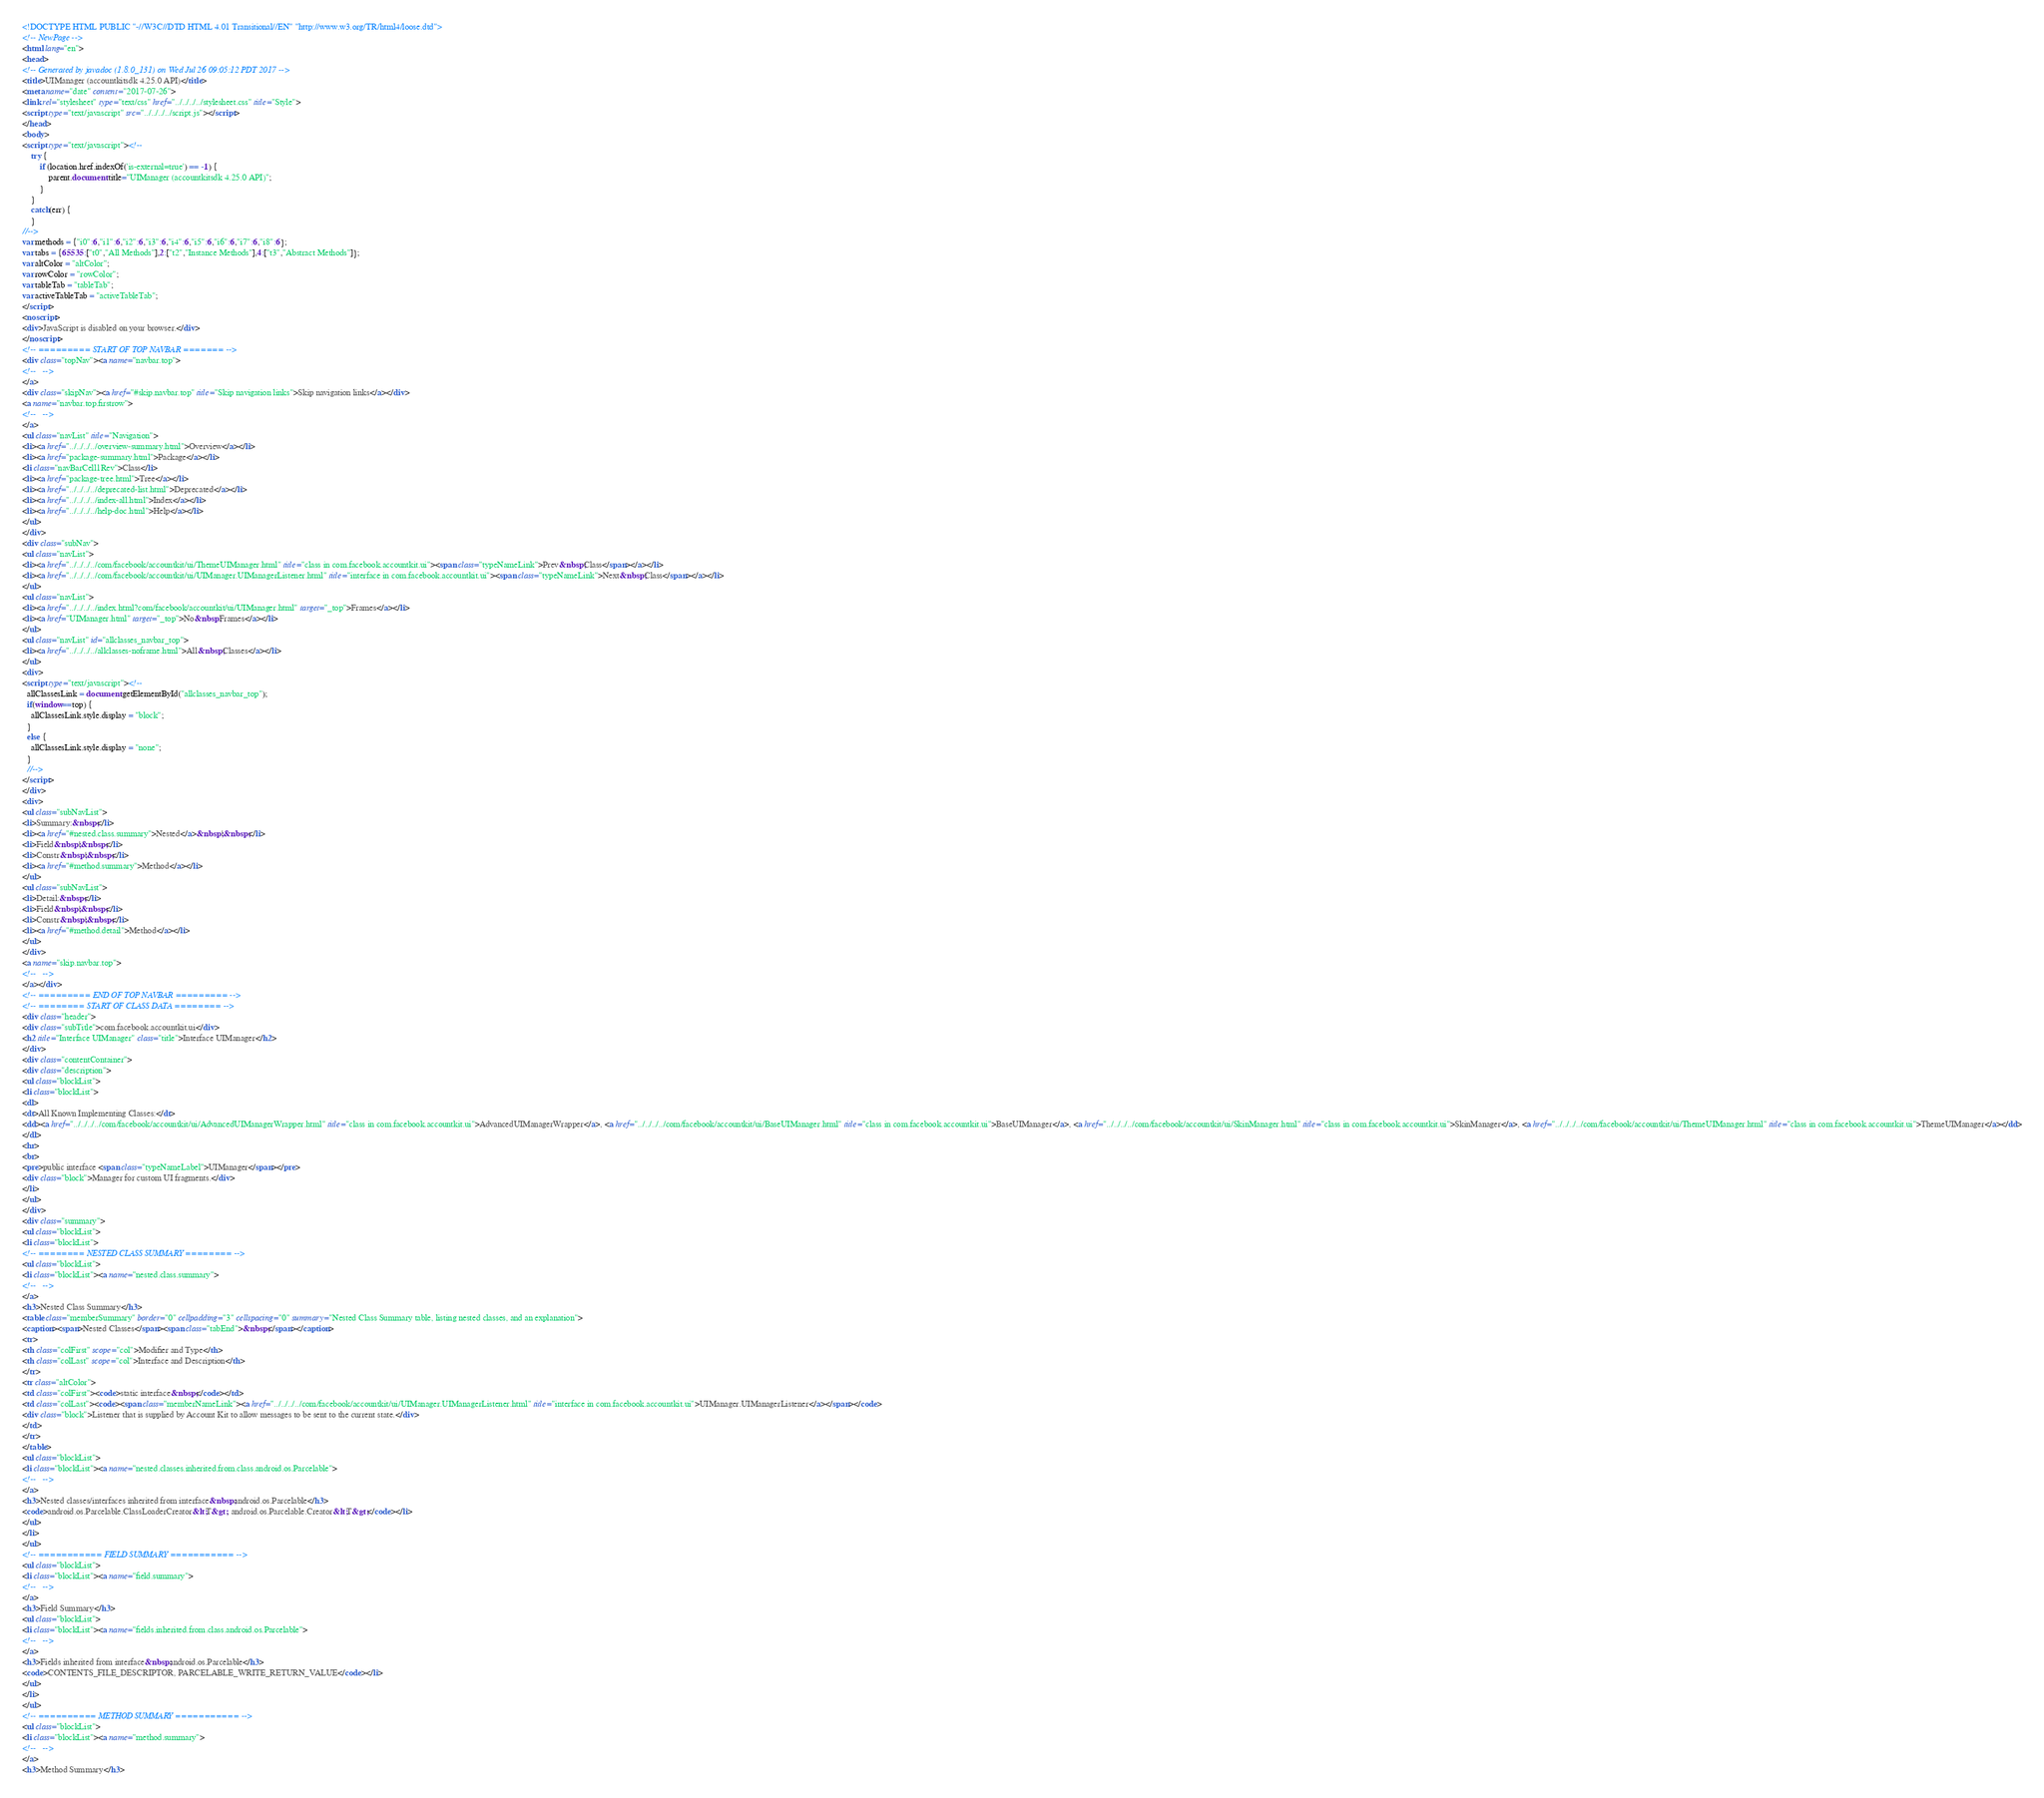Convert code to text. <code><loc_0><loc_0><loc_500><loc_500><_HTML_><!DOCTYPE HTML PUBLIC "-//W3C//DTD HTML 4.01 Transitional//EN" "http://www.w3.org/TR/html4/loose.dtd">
<!-- NewPage -->
<html lang="en">
<head>
<!-- Generated by javadoc (1.8.0_131) on Wed Jul 26 09:05:12 PDT 2017 -->
<title>UIManager (accountkitsdk 4.25.0 API)</title>
<meta name="date" content="2017-07-26">
<link rel="stylesheet" type="text/css" href="../../../../stylesheet.css" title="Style">
<script type="text/javascript" src="../../../../script.js"></script>
</head>
<body>
<script type="text/javascript"><!--
    try {
        if (location.href.indexOf('is-external=true') == -1) {
            parent.document.title="UIManager (accountkitsdk 4.25.0 API)";
        }
    }
    catch(err) {
    }
//-->
var methods = {"i0":6,"i1":6,"i2":6,"i3":6,"i4":6,"i5":6,"i6":6,"i7":6,"i8":6};
var tabs = {65535:["t0","All Methods"],2:["t2","Instance Methods"],4:["t3","Abstract Methods"]};
var altColor = "altColor";
var rowColor = "rowColor";
var tableTab = "tableTab";
var activeTableTab = "activeTableTab";
</script>
<noscript>
<div>JavaScript is disabled on your browser.</div>
</noscript>
<!-- ========= START OF TOP NAVBAR ======= -->
<div class="topNav"><a name="navbar.top">
<!--   -->
</a>
<div class="skipNav"><a href="#skip.navbar.top" title="Skip navigation links">Skip navigation links</a></div>
<a name="navbar.top.firstrow">
<!--   -->
</a>
<ul class="navList" title="Navigation">
<li><a href="../../../../overview-summary.html">Overview</a></li>
<li><a href="package-summary.html">Package</a></li>
<li class="navBarCell1Rev">Class</li>
<li><a href="package-tree.html">Tree</a></li>
<li><a href="../../../../deprecated-list.html">Deprecated</a></li>
<li><a href="../../../../index-all.html">Index</a></li>
<li><a href="../../../../help-doc.html">Help</a></li>
</ul>
</div>
<div class="subNav">
<ul class="navList">
<li><a href="../../../../com/facebook/accountkit/ui/ThemeUIManager.html" title="class in com.facebook.accountkit.ui"><span class="typeNameLink">Prev&nbsp;Class</span></a></li>
<li><a href="../../../../com/facebook/accountkit/ui/UIManager.UIManagerListener.html" title="interface in com.facebook.accountkit.ui"><span class="typeNameLink">Next&nbsp;Class</span></a></li>
</ul>
<ul class="navList">
<li><a href="../../../../index.html?com/facebook/accountkit/ui/UIManager.html" target="_top">Frames</a></li>
<li><a href="UIManager.html" target="_top">No&nbsp;Frames</a></li>
</ul>
<ul class="navList" id="allclasses_navbar_top">
<li><a href="../../../../allclasses-noframe.html">All&nbsp;Classes</a></li>
</ul>
<div>
<script type="text/javascript"><!--
  allClassesLink = document.getElementById("allclasses_navbar_top");
  if(window==top) {
    allClassesLink.style.display = "block";
  }
  else {
    allClassesLink.style.display = "none";
  }
  //-->
</script>
</div>
<div>
<ul class="subNavList">
<li>Summary:&nbsp;</li>
<li><a href="#nested.class.summary">Nested</a>&nbsp;|&nbsp;</li>
<li>Field&nbsp;|&nbsp;</li>
<li>Constr&nbsp;|&nbsp;</li>
<li><a href="#method.summary">Method</a></li>
</ul>
<ul class="subNavList">
<li>Detail:&nbsp;</li>
<li>Field&nbsp;|&nbsp;</li>
<li>Constr&nbsp;|&nbsp;</li>
<li><a href="#method.detail">Method</a></li>
</ul>
</div>
<a name="skip.navbar.top">
<!--   -->
</a></div>
<!-- ========= END OF TOP NAVBAR ========= -->
<!-- ======== START OF CLASS DATA ======== -->
<div class="header">
<div class="subTitle">com.facebook.accountkit.ui</div>
<h2 title="Interface UIManager" class="title">Interface UIManager</h2>
</div>
<div class="contentContainer">
<div class="description">
<ul class="blockList">
<li class="blockList">
<dl>
<dt>All Known Implementing Classes:</dt>
<dd><a href="../../../../com/facebook/accountkit/ui/AdvancedUIManagerWrapper.html" title="class in com.facebook.accountkit.ui">AdvancedUIManagerWrapper</a>, <a href="../../../../com/facebook/accountkit/ui/BaseUIManager.html" title="class in com.facebook.accountkit.ui">BaseUIManager</a>, <a href="../../../../com/facebook/accountkit/ui/SkinManager.html" title="class in com.facebook.accountkit.ui">SkinManager</a>, <a href="../../../../com/facebook/accountkit/ui/ThemeUIManager.html" title="class in com.facebook.accountkit.ui">ThemeUIManager</a></dd>
</dl>
<hr>
<br>
<pre>public interface <span class="typeNameLabel">UIManager</span></pre>
<div class="block">Manager for custom UI fragments.</div>
</li>
</ul>
</div>
<div class="summary">
<ul class="blockList">
<li class="blockList">
<!-- ======== NESTED CLASS SUMMARY ======== -->
<ul class="blockList">
<li class="blockList"><a name="nested.class.summary">
<!--   -->
</a>
<h3>Nested Class Summary</h3>
<table class="memberSummary" border="0" cellpadding="3" cellspacing="0" summary="Nested Class Summary table, listing nested classes, and an explanation">
<caption><span>Nested Classes</span><span class="tabEnd">&nbsp;</span></caption>
<tr>
<th class="colFirst" scope="col">Modifier and Type</th>
<th class="colLast" scope="col">Interface and Description</th>
</tr>
<tr class="altColor">
<td class="colFirst"><code>static interface&nbsp;</code></td>
<td class="colLast"><code><span class="memberNameLink"><a href="../../../../com/facebook/accountkit/ui/UIManager.UIManagerListener.html" title="interface in com.facebook.accountkit.ui">UIManager.UIManagerListener</a></span></code>
<div class="block">Listener that is supplied by Account Kit to allow messages to be sent to the current state.</div>
</td>
</tr>
</table>
<ul class="blockList">
<li class="blockList"><a name="nested.classes.inherited.from.class.android.os.Parcelable">
<!--   -->
</a>
<h3>Nested classes/interfaces inherited from interface&nbsp;android.os.Parcelable</h3>
<code>android.os.Parcelable.ClassLoaderCreator&lt;T&gt;, android.os.Parcelable.Creator&lt;T&gt;</code></li>
</ul>
</li>
</ul>
<!-- =========== FIELD SUMMARY =========== -->
<ul class="blockList">
<li class="blockList"><a name="field.summary">
<!--   -->
</a>
<h3>Field Summary</h3>
<ul class="blockList">
<li class="blockList"><a name="fields.inherited.from.class.android.os.Parcelable">
<!--   -->
</a>
<h3>Fields inherited from interface&nbsp;android.os.Parcelable</h3>
<code>CONTENTS_FILE_DESCRIPTOR, PARCELABLE_WRITE_RETURN_VALUE</code></li>
</ul>
</li>
</ul>
<!-- ========== METHOD SUMMARY =========== -->
<ul class="blockList">
<li class="blockList"><a name="method.summary">
<!--   -->
</a>
<h3>Method Summary</h3></code> 